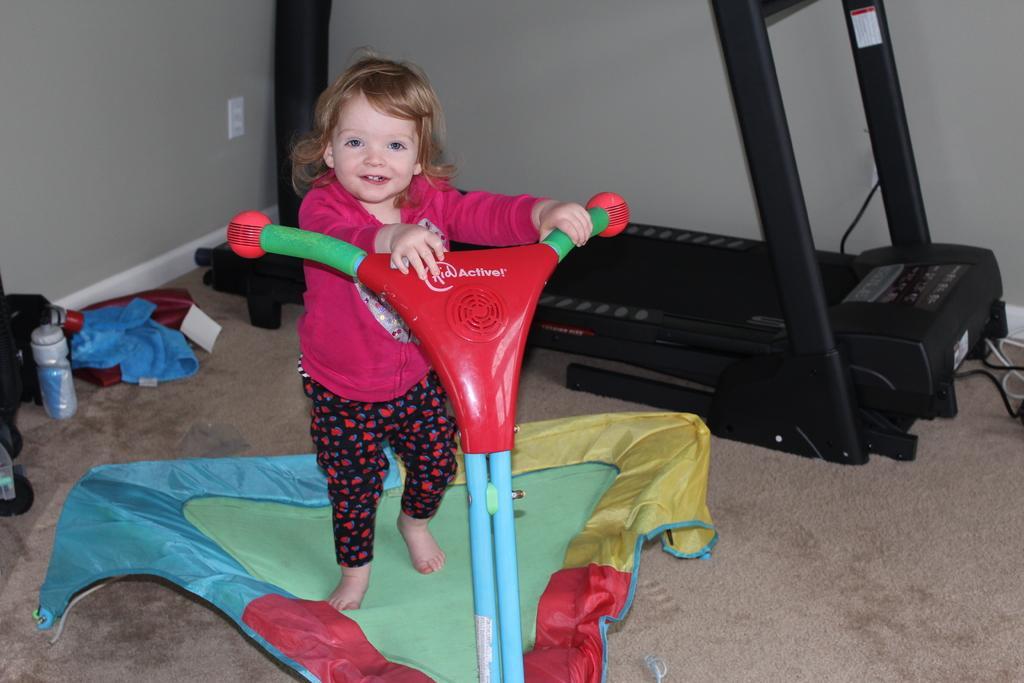Could you give a brief overview of what you see in this image? In the foreground of this image, there is a kid on the toddler vehicle on the floor. Behind her, there is a thread mill, few clothes, a bottle and few objects on the left. 